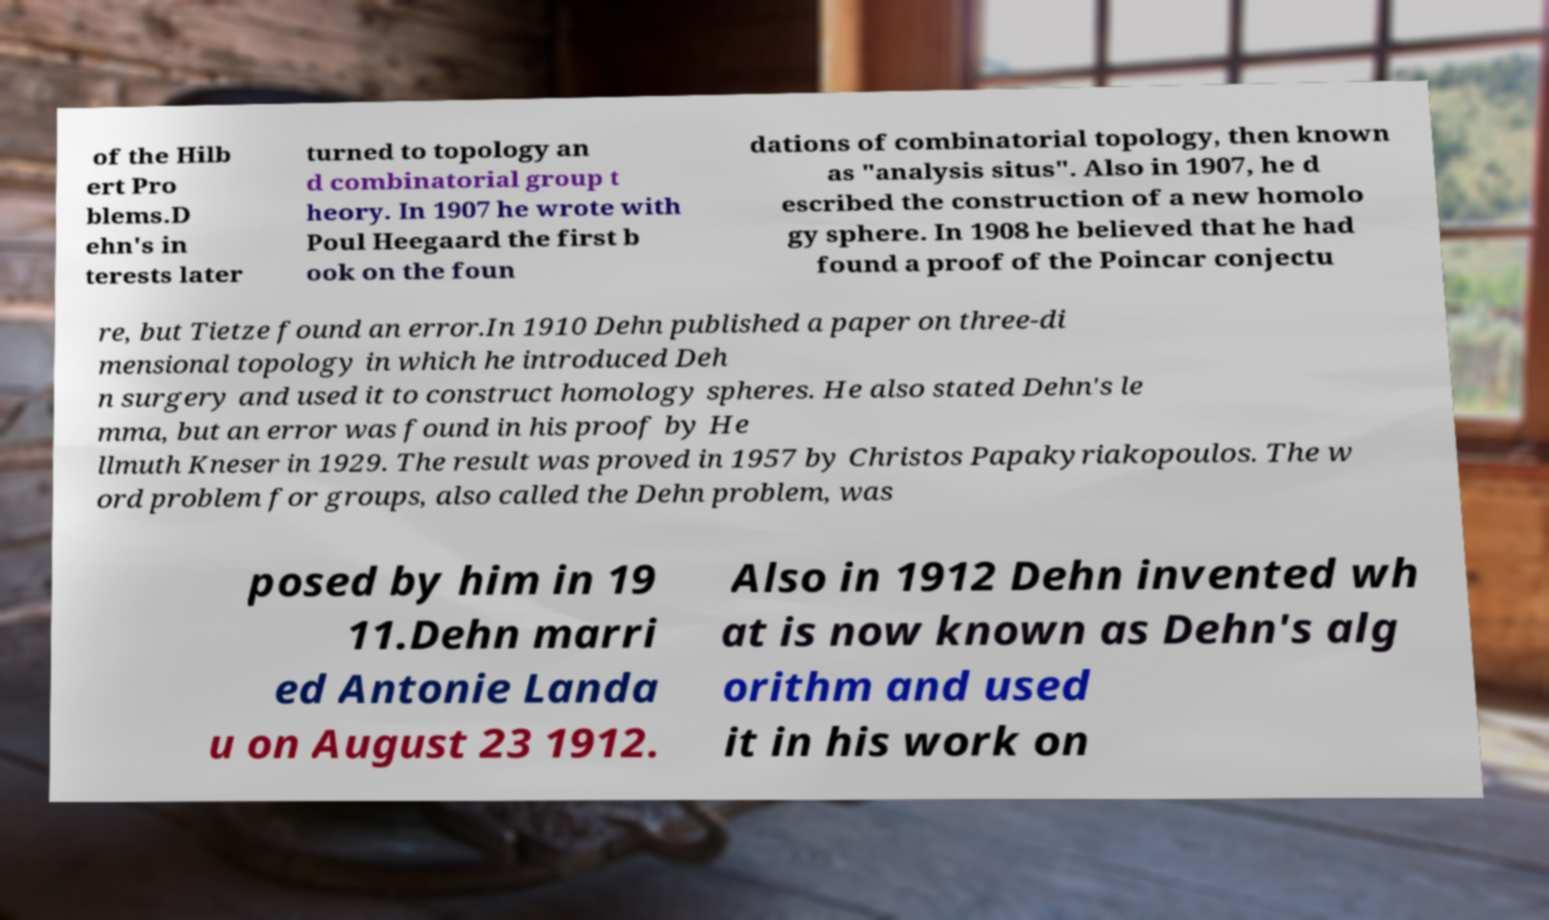Please read and relay the text visible in this image. What does it say? of the Hilb ert Pro blems.D ehn's in terests later turned to topology an d combinatorial group t heory. In 1907 he wrote with Poul Heegaard the first b ook on the foun dations of combinatorial topology, then known as "analysis situs". Also in 1907, he d escribed the construction of a new homolo gy sphere. In 1908 he believed that he had found a proof of the Poincar conjectu re, but Tietze found an error.In 1910 Dehn published a paper on three-di mensional topology in which he introduced Deh n surgery and used it to construct homology spheres. He also stated Dehn's le mma, but an error was found in his proof by He llmuth Kneser in 1929. The result was proved in 1957 by Christos Papakyriakopoulos. The w ord problem for groups, also called the Dehn problem, was posed by him in 19 11.Dehn marri ed Antonie Landa u on August 23 1912. Also in 1912 Dehn invented wh at is now known as Dehn's alg orithm and used it in his work on 